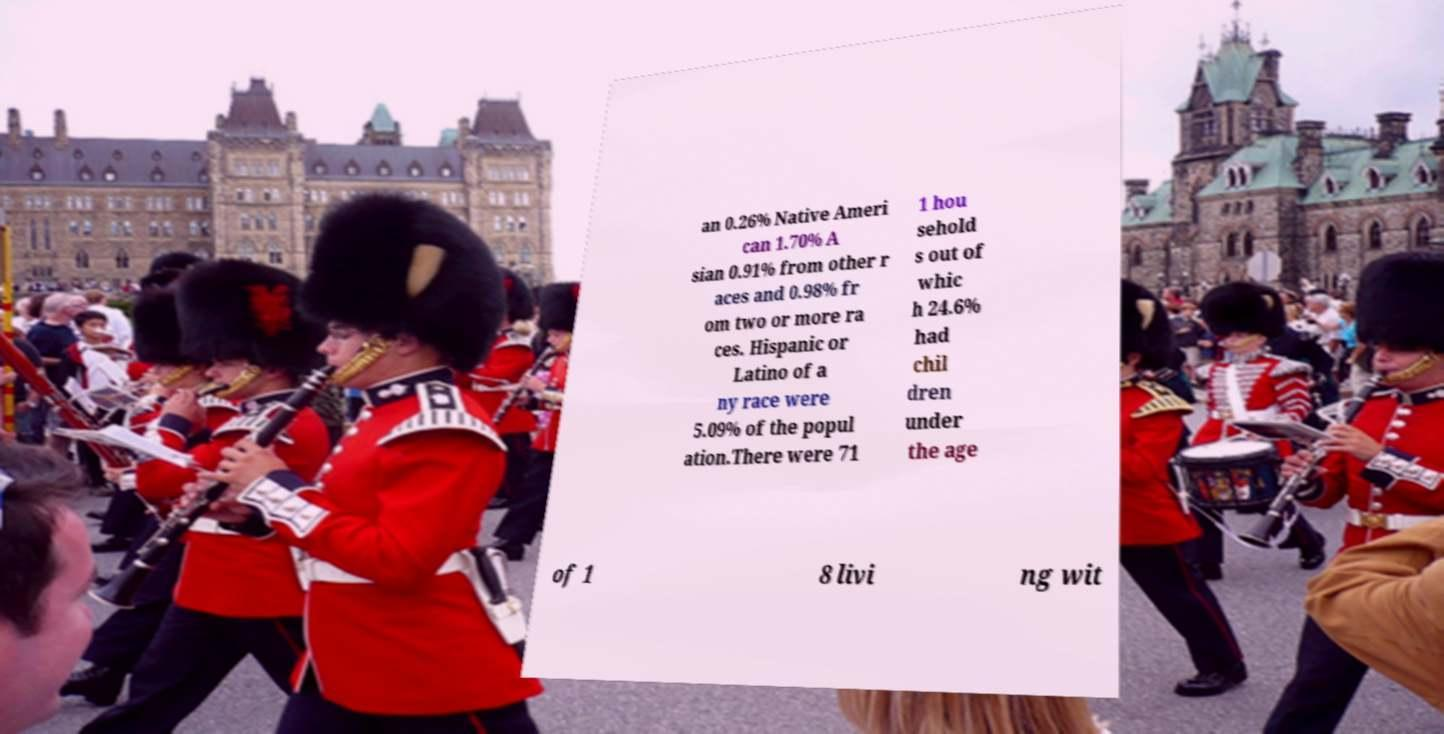There's text embedded in this image that I need extracted. Can you transcribe it verbatim? an 0.26% Native Ameri can 1.70% A sian 0.91% from other r aces and 0.98% fr om two or more ra ces. Hispanic or Latino of a ny race were 5.09% of the popul ation.There were 71 1 hou sehold s out of whic h 24.6% had chil dren under the age of 1 8 livi ng wit 